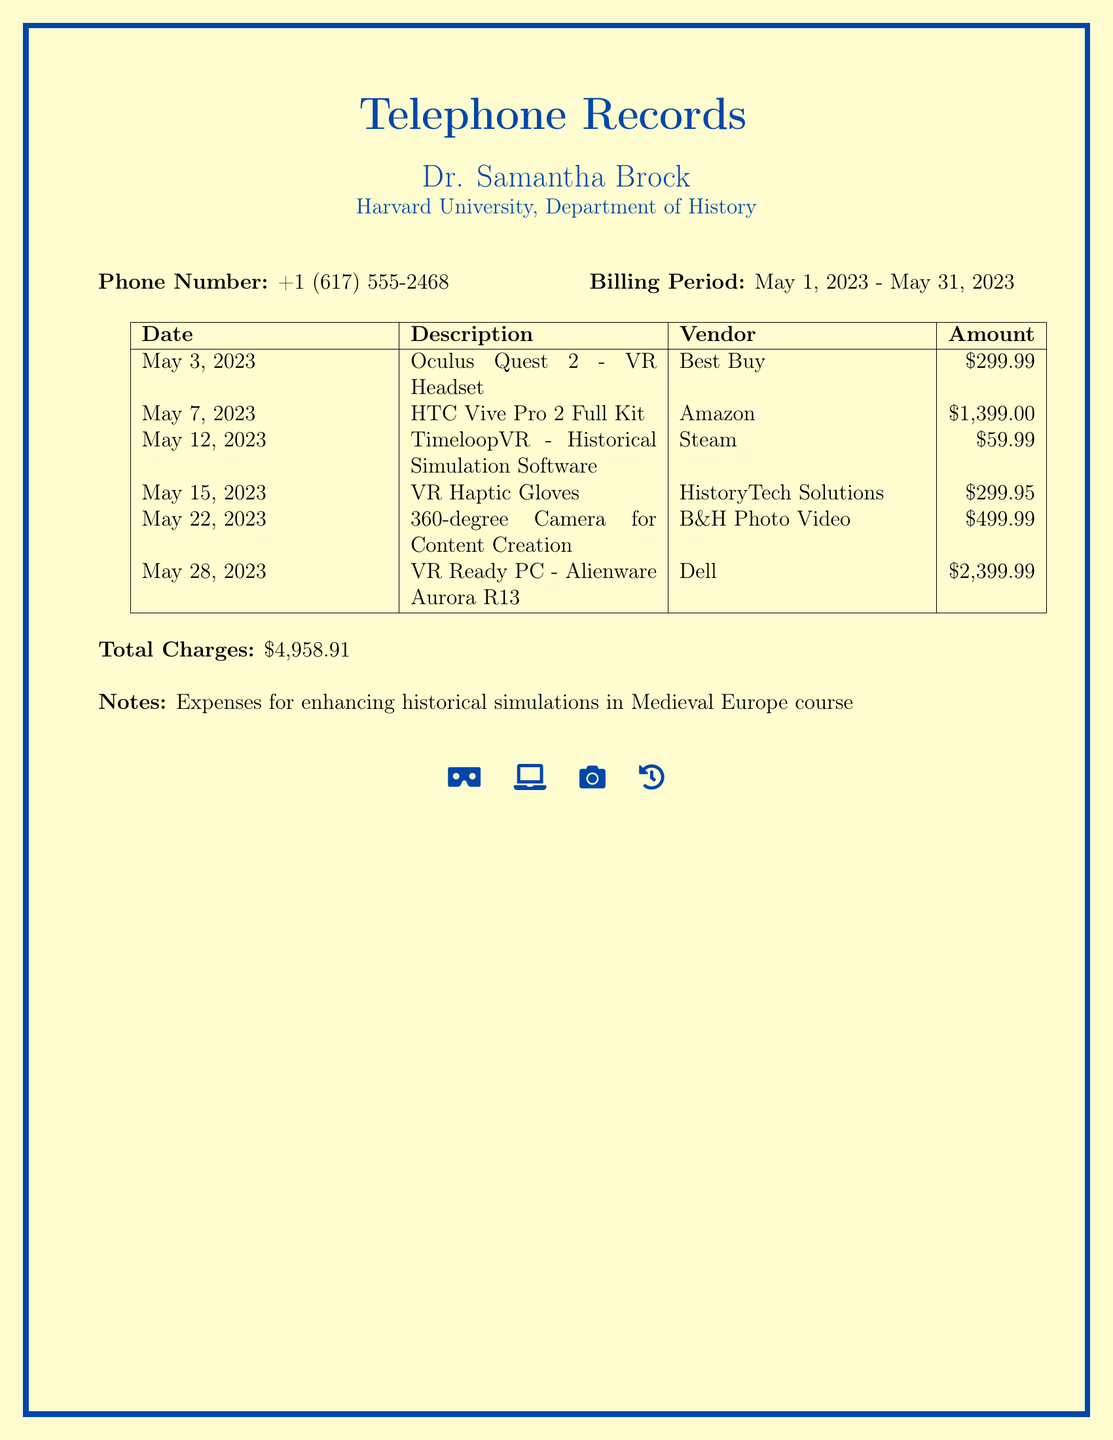What is the phone number? The phone number is listed in the document as the contact number for Dr. Samantha Brock.
Answer: +1 (617) 555-2468 What is the billing period? The billing period specifies the timeframe during which the charges were incurred, detailed as May 1, 2023 - May 31, 2023.
Answer: May 1, 2023 - May 31, 2023 What is the total amount charged? The total amount charged aggregates all expenses listed in the document and is identified at the bottom.
Answer: $4,958.91 How many items were purchased? The number of distinct purchases made for virtual reality equipment and software is indicated by the entries in the document.
Answer: 6 Which vendor supplied the VR Ready PC? One of the items purchased is the VR Ready PC, listed with the associated vendor in the record.
Answer: Dell What type of software was purchased on May 12, 2023? The software purchase is specifically related to historical simulations, indicating its purpose.
Answer: Historical Simulation Software What was the price of the 360-degree camera? The price of the camera is provided in the document and reflects its cost during the billing period.
Answer: $499.99 What is the description of the item purchased on May 15, 2023? This date features a purchase that enhances user interactivity and experience during simulations.
Answer: VR Haptic Gloves What are the notes regarding the expenses? The notes provide context for the expenses, indicating their relevance to a specific course.
Answer: Enhancing historical simulations in Medieval Europe course 